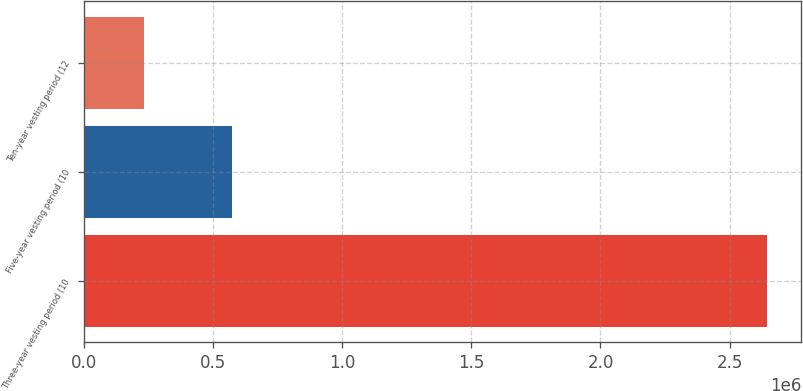Convert chart. <chart><loc_0><loc_0><loc_500><loc_500><bar_chart><fcel>Three-year vesting period (10<fcel>Five-year vesting period (10<fcel>Ten-year vesting period (12<nl><fcel>2.64534e+06<fcel>573793<fcel>232566<nl></chart> 